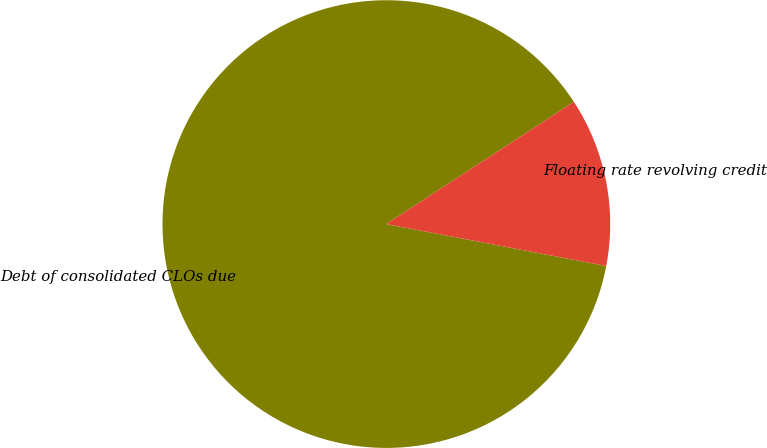Convert chart. <chart><loc_0><loc_0><loc_500><loc_500><pie_chart><fcel>Debt of consolidated CLOs due<fcel>Floating rate revolving credit<nl><fcel>87.81%<fcel>12.19%<nl></chart> 